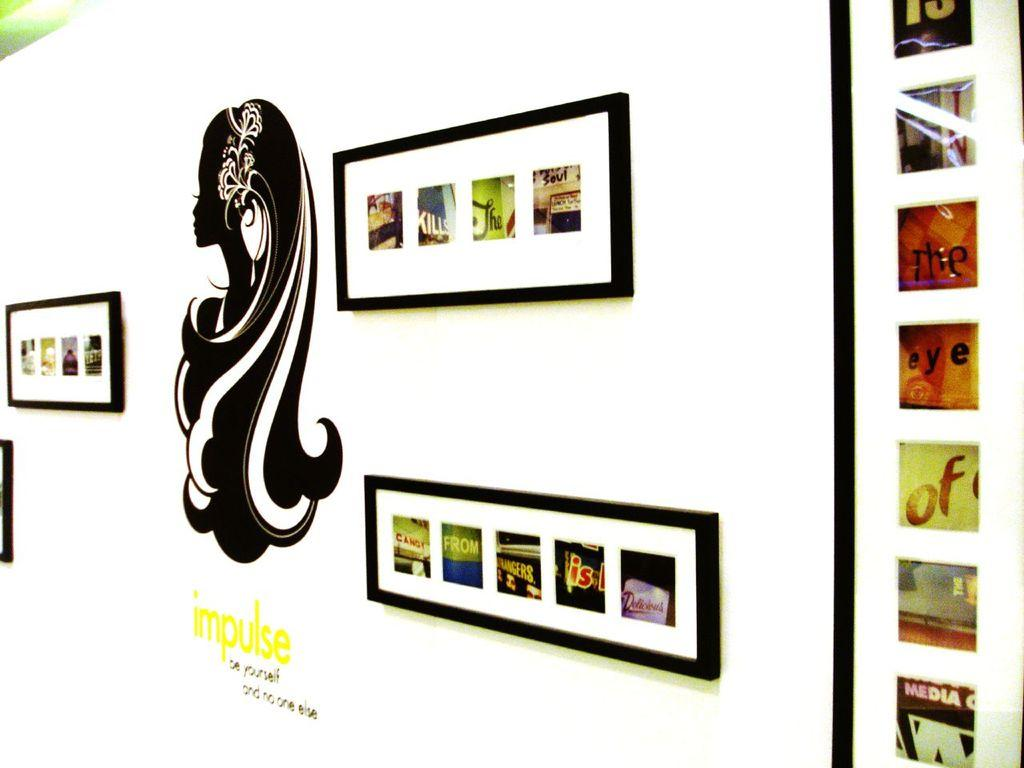<image>
Provide a brief description of the given image. The word impulse is painted in yellow on a wall displaying several photographs. 